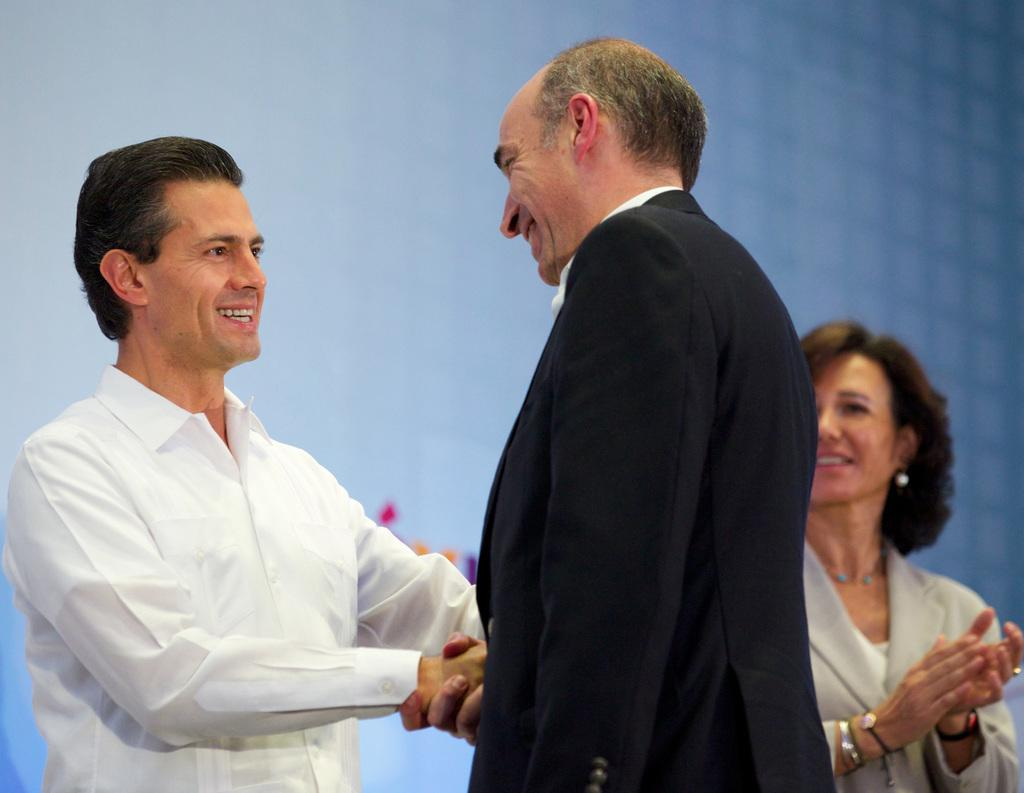What are the two people in the image doing? The two people in the image are shaking hands. How do the people in the image appear to feel? Both people have smiles on their faces, indicating that they are happy or pleased. What is happening in the background of the image? There is a woman clapping in the background, and a screen is visible. What type of trail can be seen in the image? There is no trail present in the image. What is the zinc content of the handshake in the image? There is no zinc content to be measured in the handshake, as it is a physical gesture between two people. 